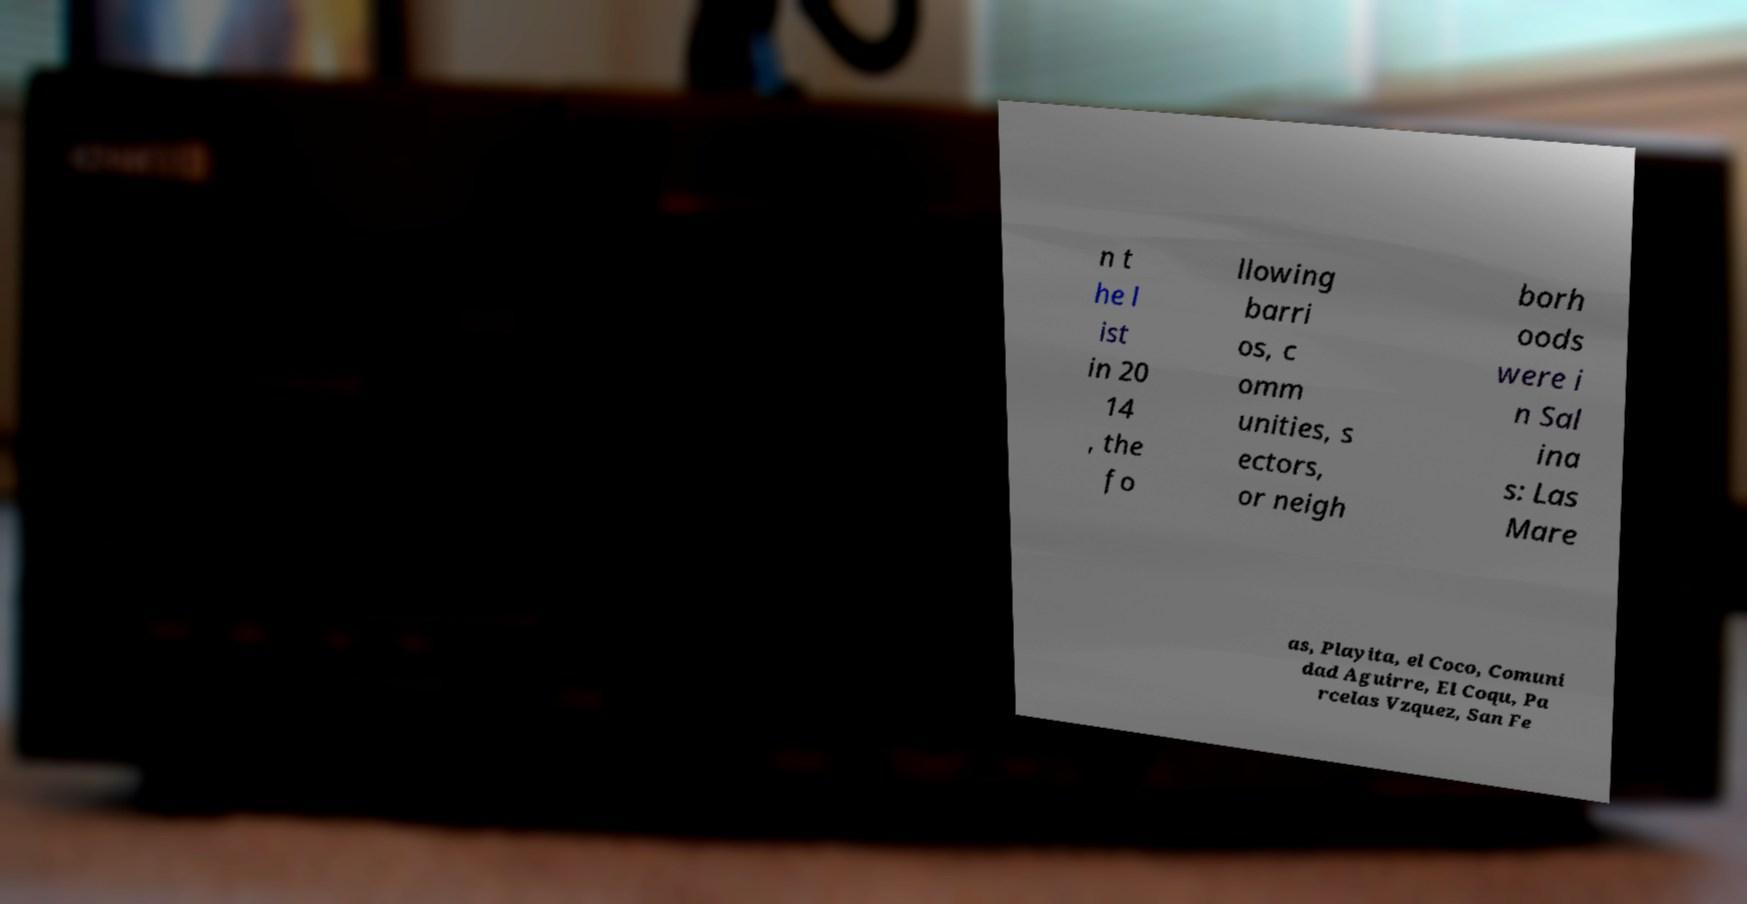Please read and relay the text visible in this image. What does it say? n t he l ist in 20 14 , the fo llowing barri os, c omm unities, s ectors, or neigh borh oods were i n Sal ina s: Las Mare as, Playita, el Coco, Comuni dad Aguirre, El Coqu, Pa rcelas Vzquez, San Fe 